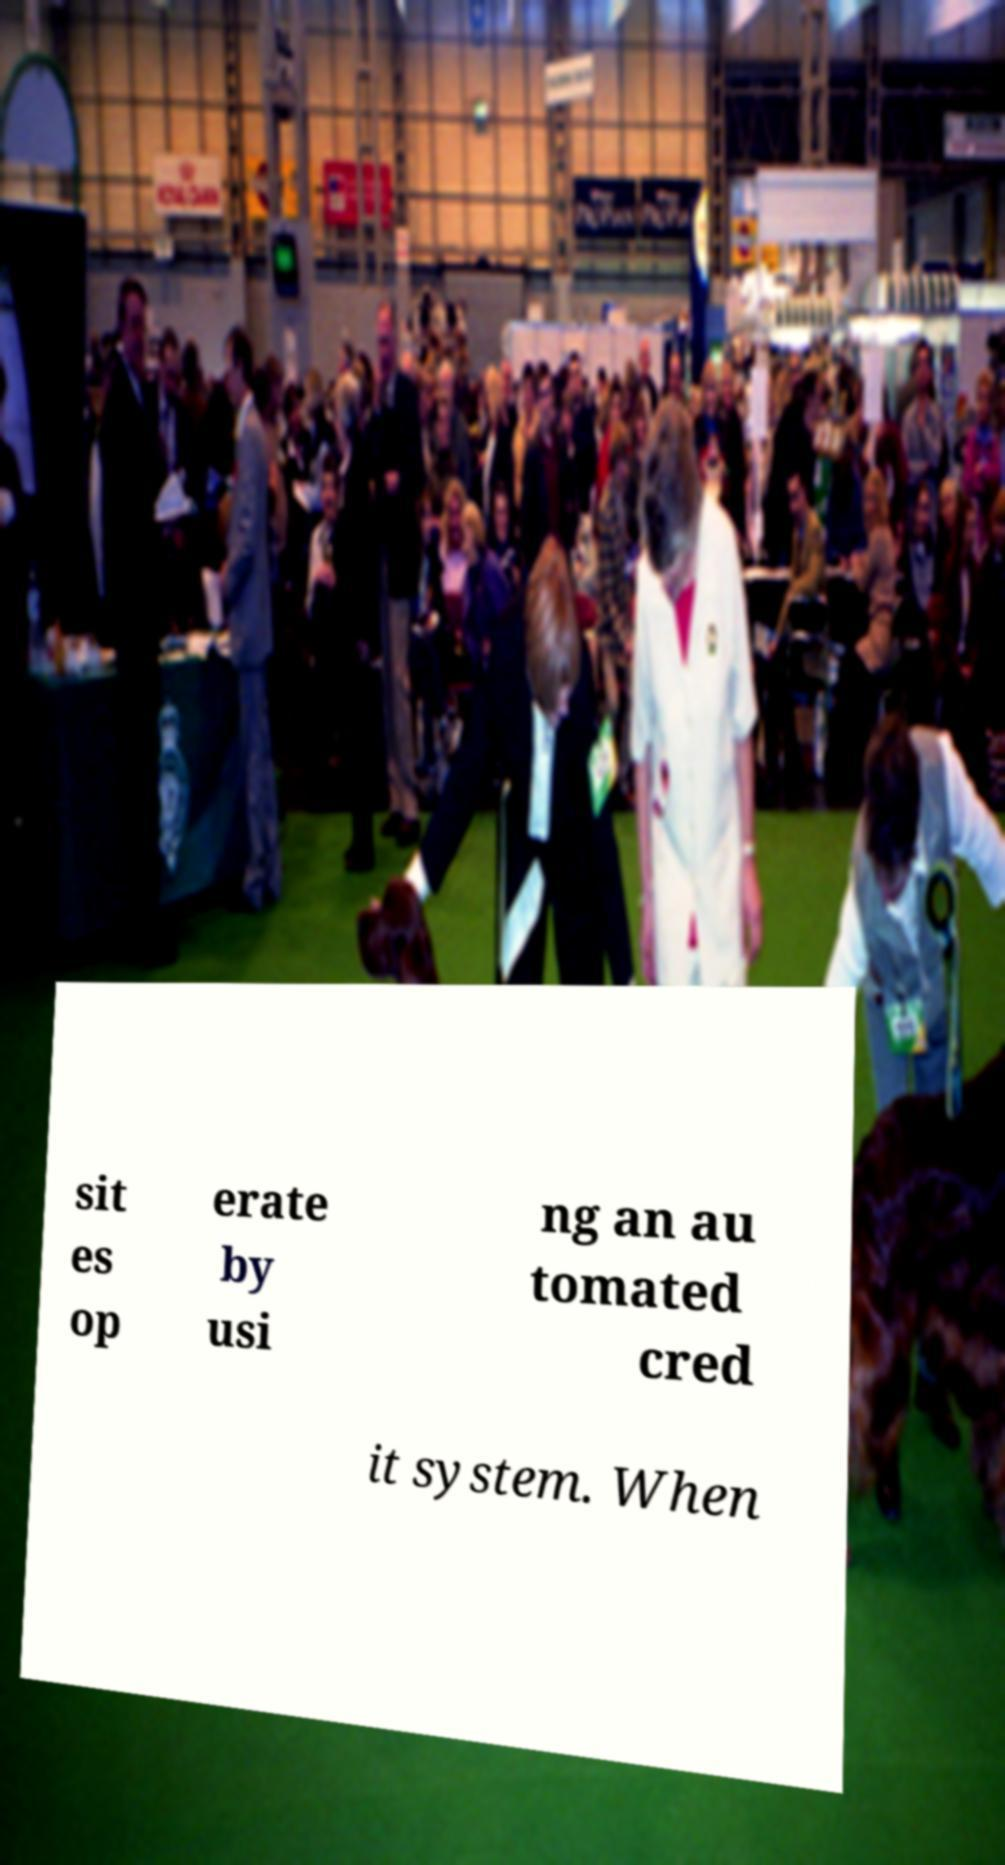Could you assist in decoding the text presented in this image and type it out clearly? sit es op erate by usi ng an au tomated cred it system. When 